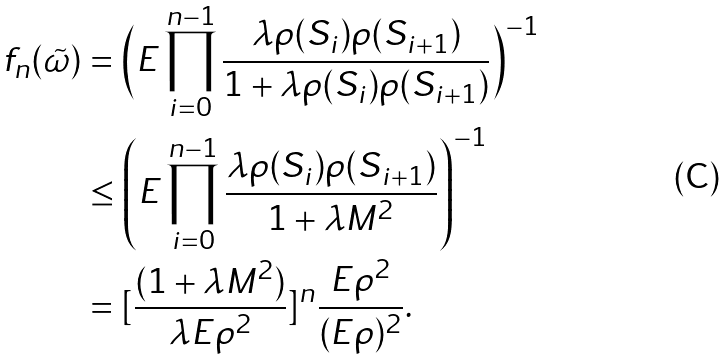<formula> <loc_0><loc_0><loc_500><loc_500>f _ { n } ( \tilde { \omega } ) & = \Big { ( } E \prod _ { i = 0 } ^ { n - 1 } \frac { \lambda \rho ( S _ { i } ) \rho ( S _ { i + 1 } ) } { 1 + \lambda \rho ( S _ { i } ) \rho ( S _ { i + 1 } ) } \Big { ) } ^ { - 1 } \\ & \leq \left ( E \prod _ { i = 0 } ^ { n - 1 } \frac { \lambda \rho ( S _ { i } ) \rho ( S _ { i + 1 } ) } { 1 + \lambda M ^ { 2 } } \right ) ^ { - 1 } \\ & = [ \frac { ( 1 + \lambda M ^ { 2 } ) } { \lambda E \rho ^ { 2 } } ] ^ { n } \frac { E \rho ^ { 2 } } { ( E \rho ) ^ { 2 } } .</formula> 